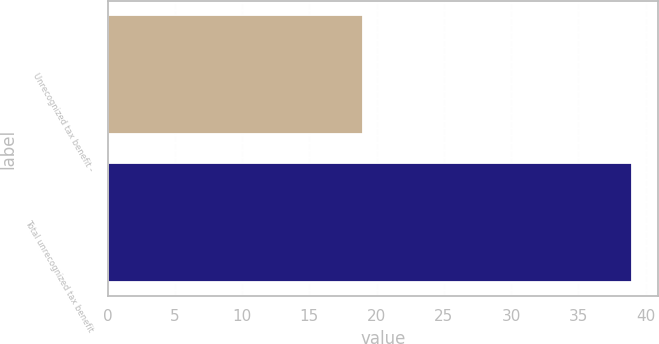Convert chart to OTSL. <chart><loc_0><loc_0><loc_500><loc_500><bar_chart><fcel>Unrecognized tax benefit -<fcel>Total unrecognized tax benefit<nl><fcel>19<fcel>39<nl></chart> 